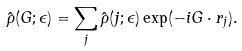Convert formula to latex. <formula><loc_0><loc_0><loc_500><loc_500>\hat { \rho } ( { G } ; \epsilon ) = \sum _ { j } \hat { \rho } ( j ; \epsilon ) \exp ( - i { G } \cdot { r } _ { j } ) .</formula> 